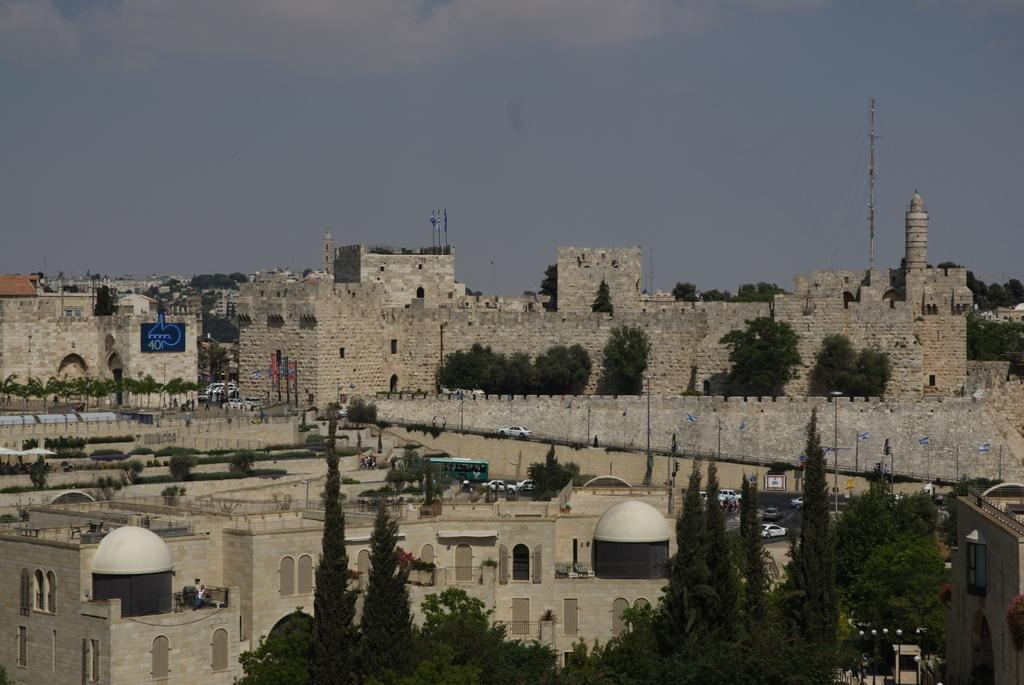What type of structures can be seen in the image? There are buildings in the image. What else can be seen in the image besides buildings? There are trees, vehicles, and flags with poles in the image. What is visible in the background of the image? The sky is visible in the background of the image. Can you see any boats in the image? There are no boats present in the image. What type of net is being used to catch the argument in the image? There is no net or argument present in the image. 